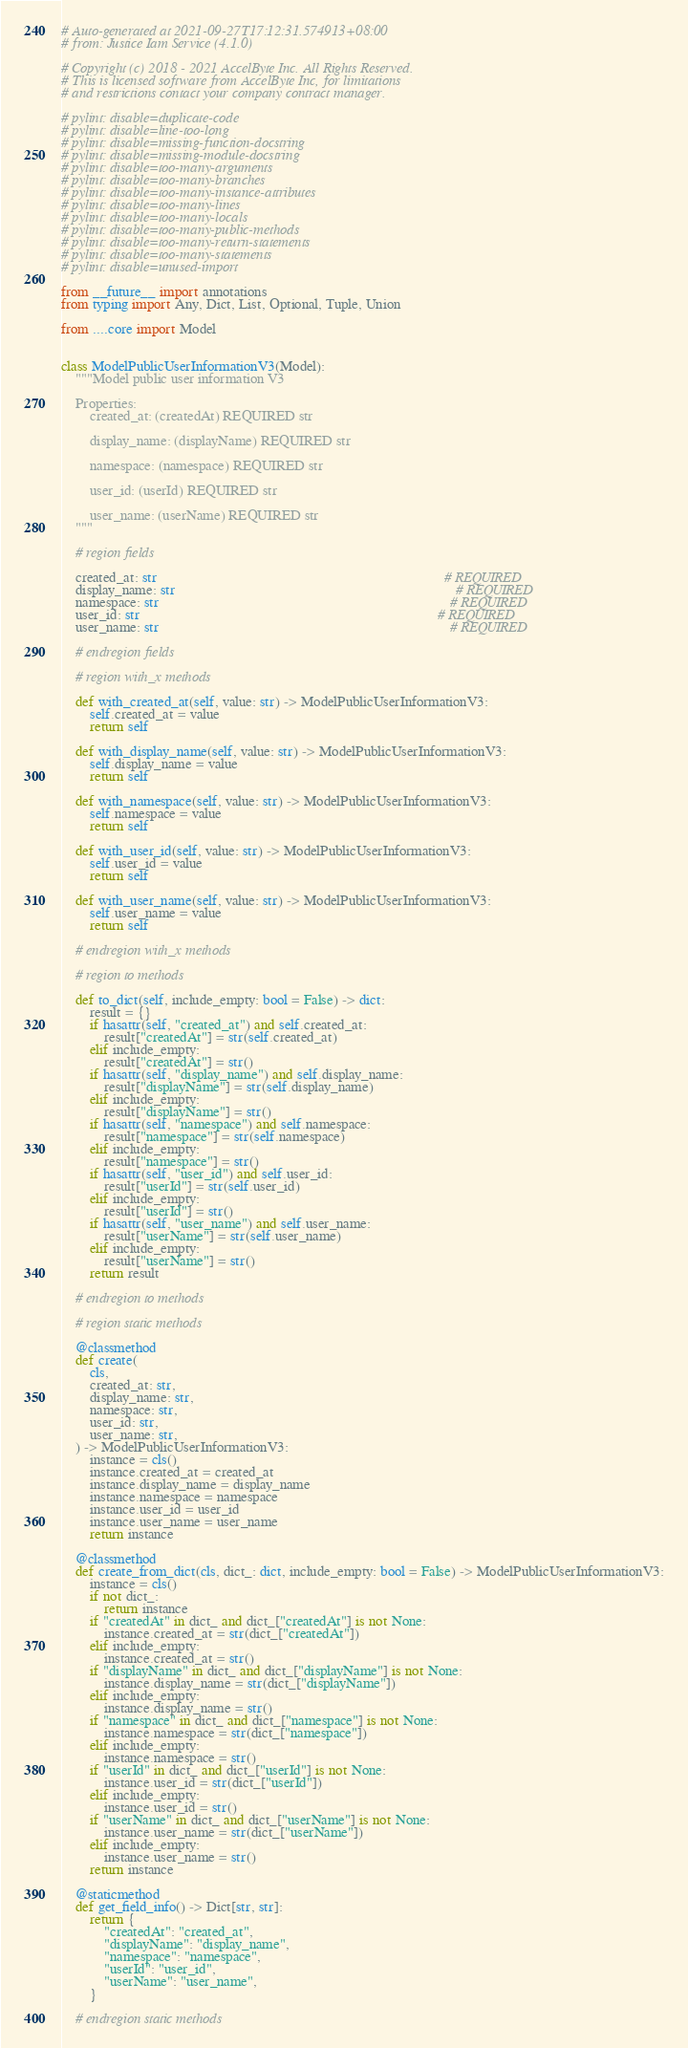Convert code to text. <code><loc_0><loc_0><loc_500><loc_500><_Python_># Auto-generated at 2021-09-27T17:12:31.574913+08:00
# from: Justice Iam Service (4.1.0)

# Copyright (c) 2018 - 2021 AccelByte Inc. All Rights Reserved.
# This is licensed software from AccelByte Inc, for limitations
# and restrictions contact your company contract manager.

# pylint: disable=duplicate-code
# pylint: disable=line-too-long
# pylint: disable=missing-function-docstring
# pylint: disable=missing-module-docstring
# pylint: disable=too-many-arguments
# pylint: disable=too-many-branches
# pylint: disable=too-many-instance-attributes
# pylint: disable=too-many-lines
# pylint: disable=too-many-locals
# pylint: disable=too-many-public-methods
# pylint: disable=too-many-return-statements
# pylint: disable=too-many-statements
# pylint: disable=unused-import

from __future__ import annotations
from typing import Any, Dict, List, Optional, Tuple, Union

from ....core import Model


class ModelPublicUserInformationV3(Model):
    """Model public user information V3

    Properties:
        created_at: (createdAt) REQUIRED str

        display_name: (displayName) REQUIRED str

        namespace: (namespace) REQUIRED str

        user_id: (userId) REQUIRED str

        user_name: (userName) REQUIRED str
    """

    # region fields

    created_at: str                                                                                # REQUIRED
    display_name: str                                                                              # REQUIRED
    namespace: str                                                                                 # REQUIRED
    user_id: str                                                                                   # REQUIRED
    user_name: str                                                                                 # REQUIRED

    # endregion fields

    # region with_x methods

    def with_created_at(self, value: str) -> ModelPublicUserInformationV3:
        self.created_at = value
        return self

    def with_display_name(self, value: str) -> ModelPublicUserInformationV3:
        self.display_name = value
        return self

    def with_namespace(self, value: str) -> ModelPublicUserInformationV3:
        self.namespace = value
        return self

    def with_user_id(self, value: str) -> ModelPublicUserInformationV3:
        self.user_id = value
        return self

    def with_user_name(self, value: str) -> ModelPublicUserInformationV3:
        self.user_name = value
        return self

    # endregion with_x methods

    # region to methods

    def to_dict(self, include_empty: bool = False) -> dict:
        result = {}
        if hasattr(self, "created_at") and self.created_at:
            result["createdAt"] = str(self.created_at)
        elif include_empty:
            result["createdAt"] = str()
        if hasattr(self, "display_name") and self.display_name:
            result["displayName"] = str(self.display_name)
        elif include_empty:
            result["displayName"] = str()
        if hasattr(self, "namespace") and self.namespace:
            result["namespace"] = str(self.namespace)
        elif include_empty:
            result["namespace"] = str()
        if hasattr(self, "user_id") and self.user_id:
            result["userId"] = str(self.user_id)
        elif include_empty:
            result["userId"] = str()
        if hasattr(self, "user_name") and self.user_name:
            result["userName"] = str(self.user_name)
        elif include_empty:
            result["userName"] = str()
        return result

    # endregion to methods

    # region static methods

    @classmethod
    def create(
        cls,
        created_at: str,
        display_name: str,
        namespace: str,
        user_id: str,
        user_name: str,
    ) -> ModelPublicUserInformationV3:
        instance = cls()
        instance.created_at = created_at
        instance.display_name = display_name
        instance.namespace = namespace
        instance.user_id = user_id
        instance.user_name = user_name
        return instance

    @classmethod
    def create_from_dict(cls, dict_: dict, include_empty: bool = False) -> ModelPublicUserInformationV3:
        instance = cls()
        if not dict_:
            return instance
        if "createdAt" in dict_ and dict_["createdAt"] is not None:
            instance.created_at = str(dict_["createdAt"])
        elif include_empty:
            instance.created_at = str()
        if "displayName" in dict_ and dict_["displayName"] is not None:
            instance.display_name = str(dict_["displayName"])
        elif include_empty:
            instance.display_name = str()
        if "namespace" in dict_ and dict_["namespace"] is not None:
            instance.namespace = str(dict_["namespace"])
        elif include_empty:
            instance.namespace = str()
        if "userId" in dict_ and dict_["userId"] is not None:
            instance.user_id = str(dict_["userId"])
        elif include_empty:
            instance.user_id = str()
        if "userName" in dict_ and dict_["userName"] is not None:
            instance.user_name = str(dict_["userName"])
        elif include_empty:
            instance.user_name = str()
        return instance

    @staticmethod
    def get_field_info() -> Dict[str, str]:
        return {
            "createdAt": "created_at",
            "displayName": "display_name",
            "namespace": "namespace",
            "userId": "user_id",
            "userName": "user_name",
        }

    # endregion static methods
</code> 